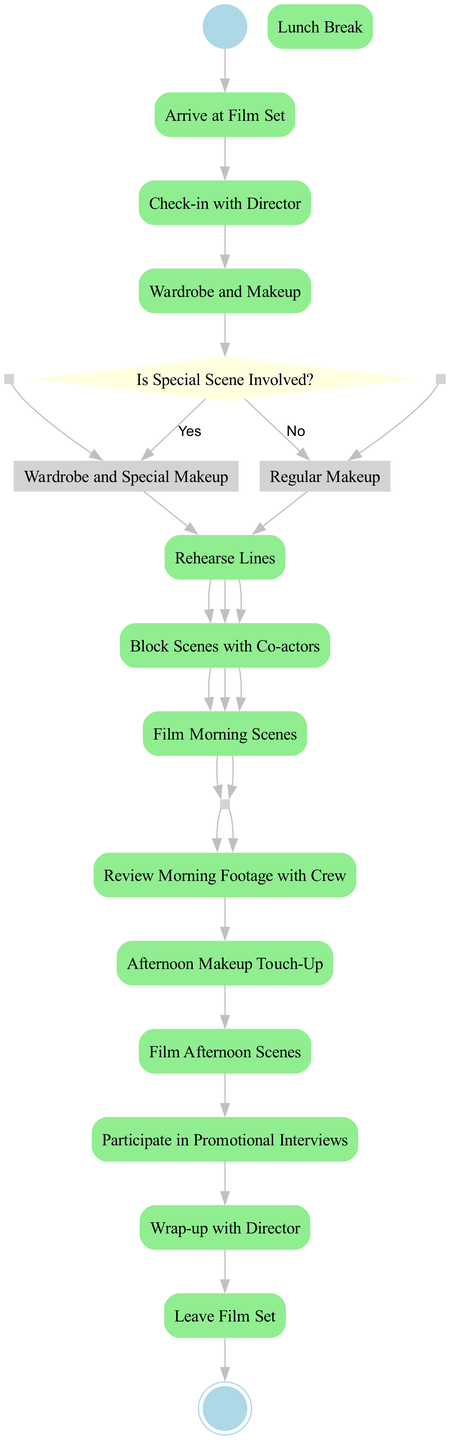What is the first activity after arriving at the film set? The diagram indicates that after arriving at the film set, the next activity is to check in with the director.
Answer: Check-in with Director How many activities are there in total? There are 13 activities listed in the diagram, starting from arrival at the film set to leaving the film set.
Answer: 13 What happens if the special scene is involved? If the special scene is involved, the actor proceeds to wardrobe and special makeup as indicated by the true path of the decision node.
Answer: Wardrobe and Special Makeup What is the last activity in the diagram? The final activity listed in the diagram is leaving the film set, which signifies the end of the daily routine.
Answer: Leave Film Set What do the join points in the diagram represent? The join points in the diagram represent the convergence of activities after the actor has completed either the regular or special scene preparations, leading into the lunch break.
Answer: Lunch Break If no special scene is involved, what makeup does the actor receive? If no special scene is involved, the actor receives regular makeup as indicated by the false path of the decision node.
Answer: Regular Makeup During which activity does the actor review morning footage? The actor reviews morning footage with the crew after the lunch break, as depicted in the flow of activities in the diagram.
Answer: Review Morning Footage with Crew What are the two forks for scene preparation? The two forks for scene preparation are Regular Scene Preparation and Special Scene Preparation, each having specific sub-activities that lead to the lunch break.
Answer: Regular Scene Preparation and Special Scene Preparation 